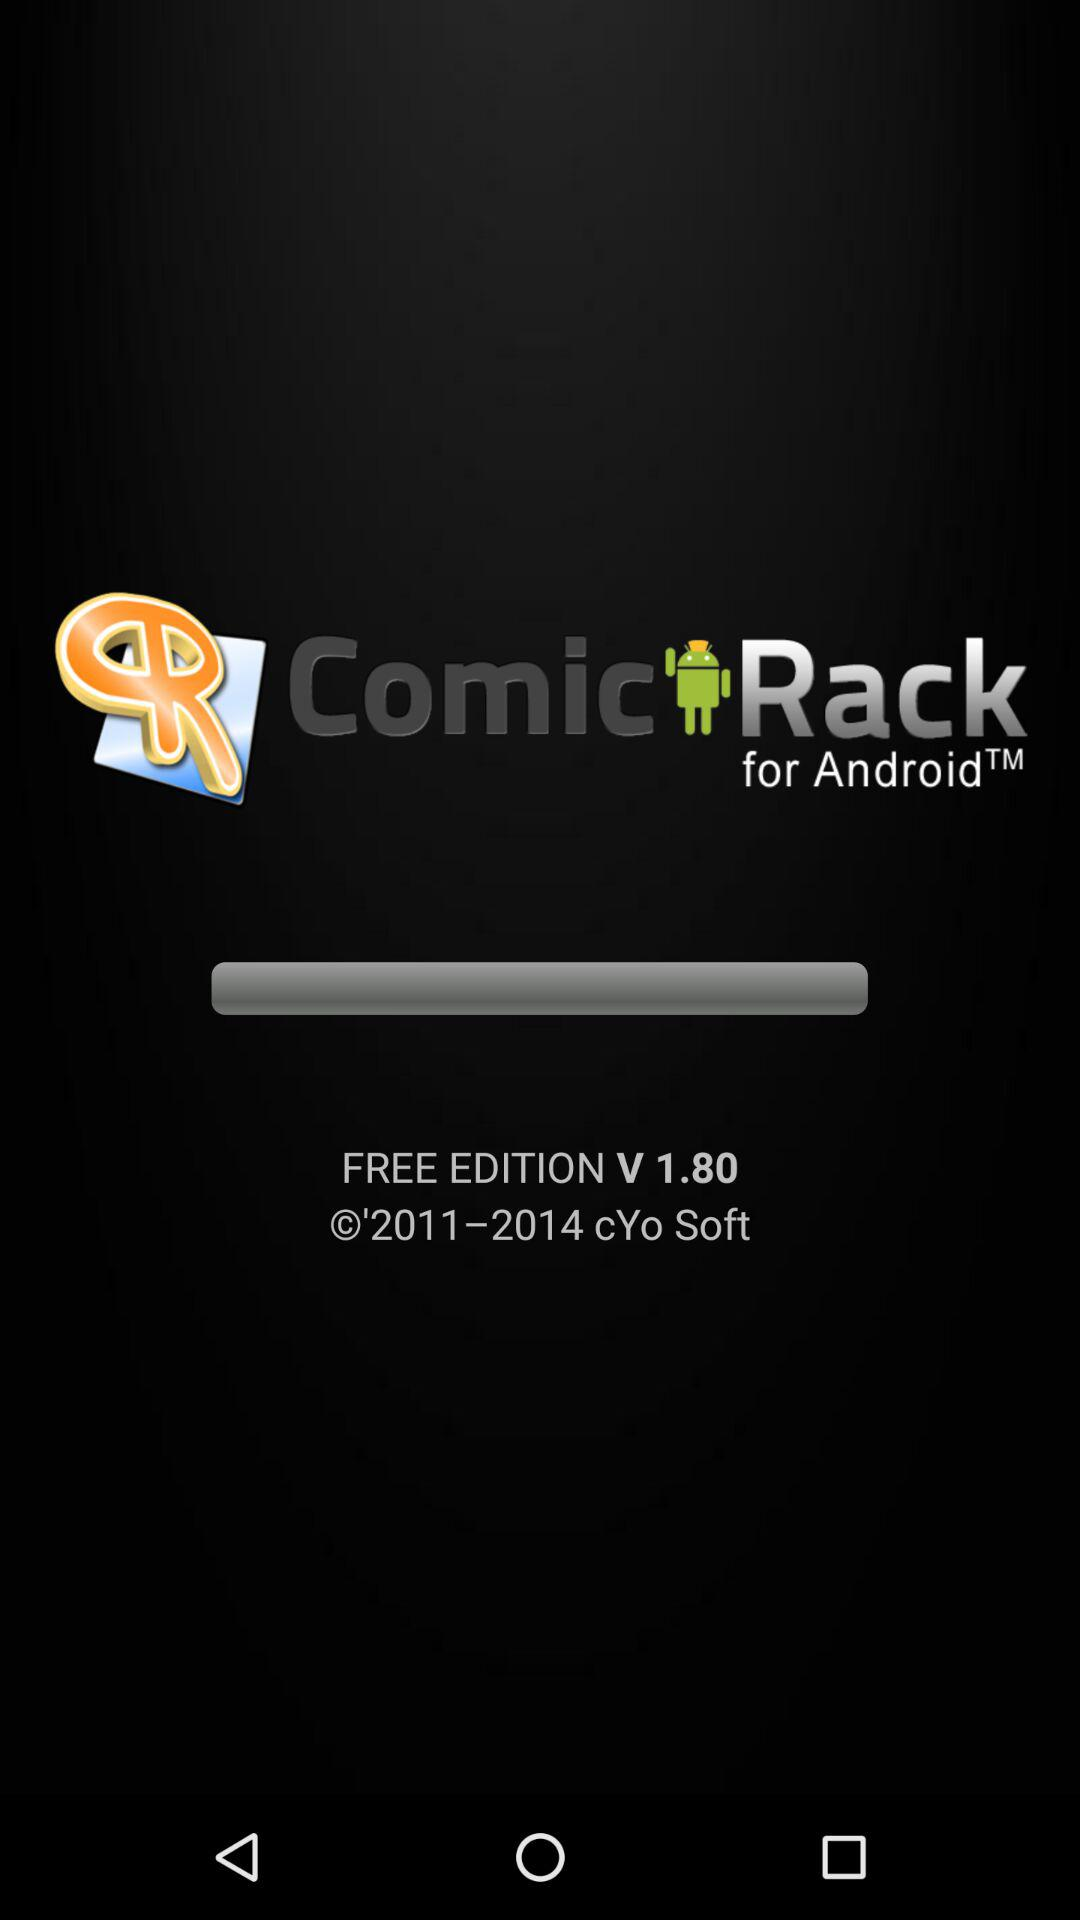What is the application name? The application name is "ComicRack". 